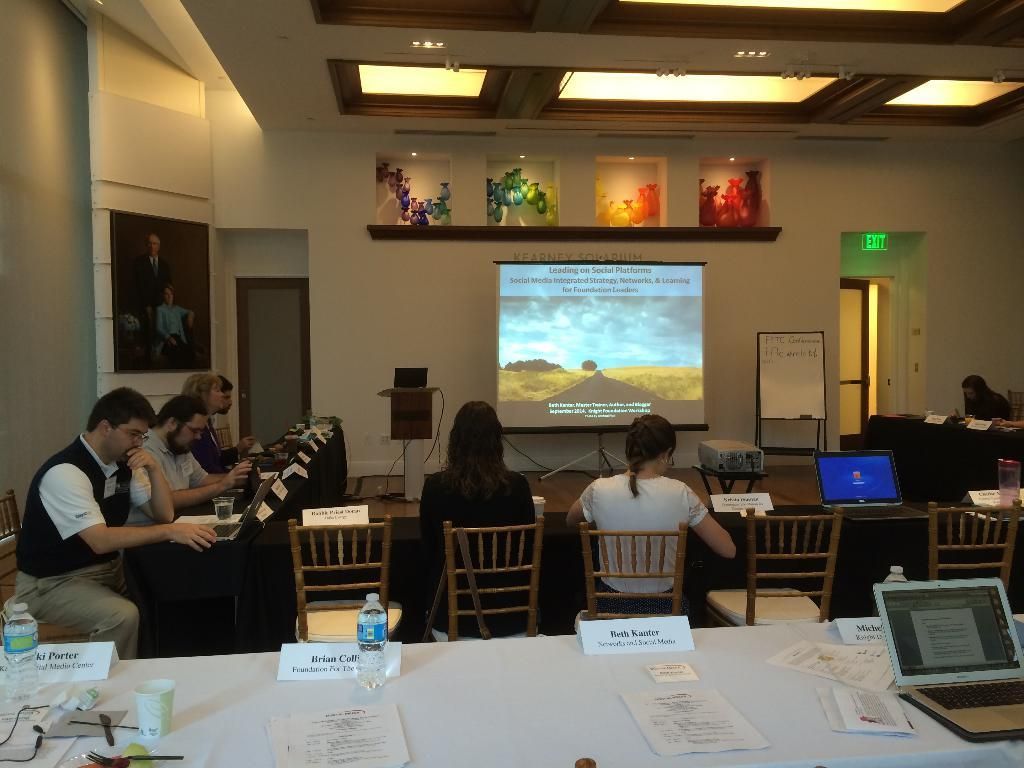What are the people in the image doing? The people in the image are sitting on a table. What is placed on top of the people? There is an LCD projector on top of the people. What else can be seen in the image besides the people and the projector? There are photographs placed in the image. What type of lighting is visible on the roof? LED lights are visible on the roof. Can you see a tree growing through the table in the image? No, there is no tree growing through the table in the image. Is there a zebra standing next to the people in the image? No, there is no zebra present in the image. 